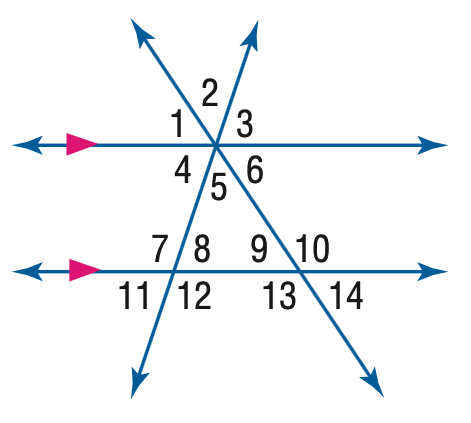Answer the mathemtical geometry problem and directly provide the correct option letter.
Question: In the figure, m \angle 11 = 62 and m \angle 14 = 38. Find the measure of \angle 8.
Choices: A: 38 B: 62 C: 118 D: 142 B 